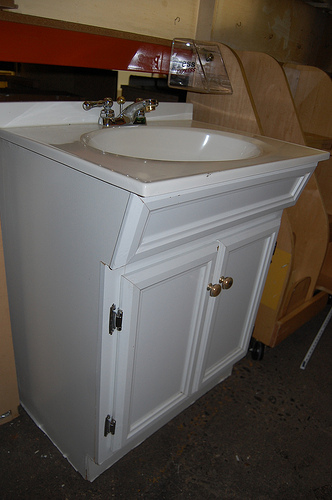<image>
Is there a vanity on the floor? Yes. Looking at the image, I can see the vanity is positioned on top of the floor, with the floor providing support. 